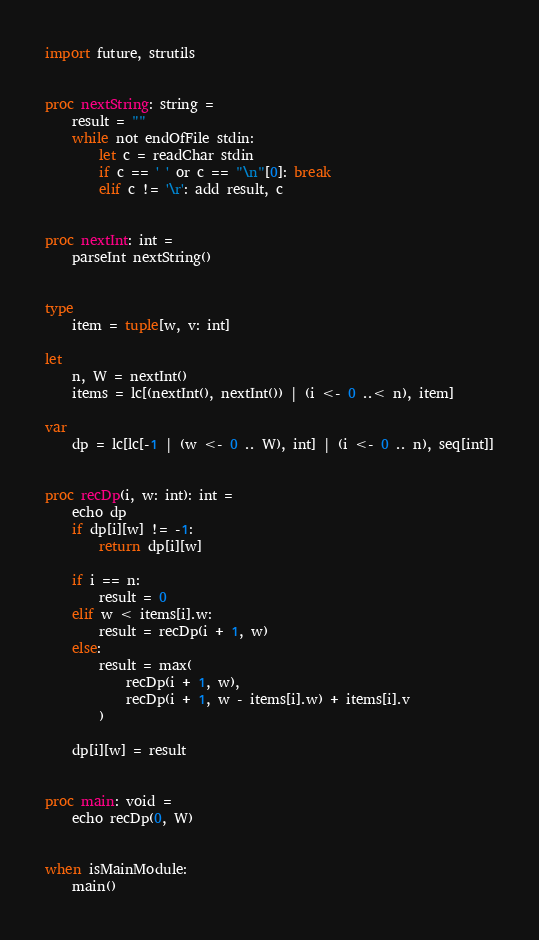Convert code to text. <code><loc_0><loc_0><loc_500><loc_500><_Nim_>import future, strutils


proc nextString: string =
    result = ""
    while not endOfFile stdin:
        let c = readChar stdin
        if c == ' ' or c == "\n"[0]: break
        elif c != '\r': add result, c


proc nextInt: int =
    parseInt nextString()


type
    item = tuple[w, v: int]

let
    n, W = nextInt()
    items = lc[(nextInt(), nextInt()) | (i <- 0 ..< n), item]

var
    dp = lc[lc[-1 | (w <- 0 .. W), int] | (i <- 0 .. n), seq[int]]


proc recDp(i, w: int): int =
    echo dp
    if dp[i][w] != -1:
        return dp[i][w]

    if i == n:
        result = 0
    elif w < items[i].w:
        result = recDp(i + 1, w)
    else:
        result = max(
            recDp(i + 1, w),
            recDp(i + 1, w - items[i].w) + items[i].v
        )

    dp[i][w] = result


proc main: void =
    echo recDp(0, W)


when isMainModule:
    main()
</code> 